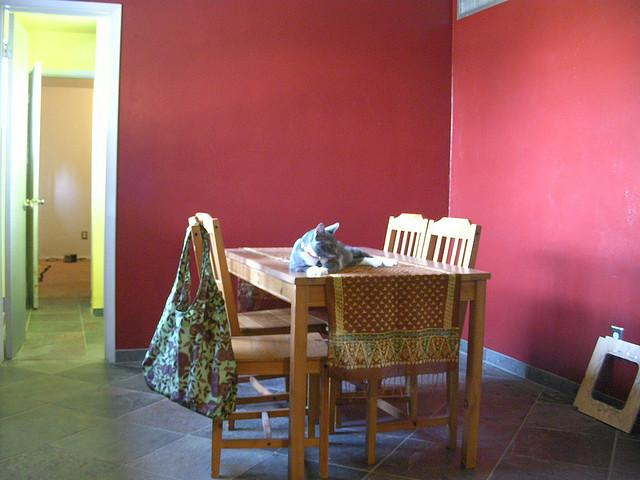What is the cat on top of? table 